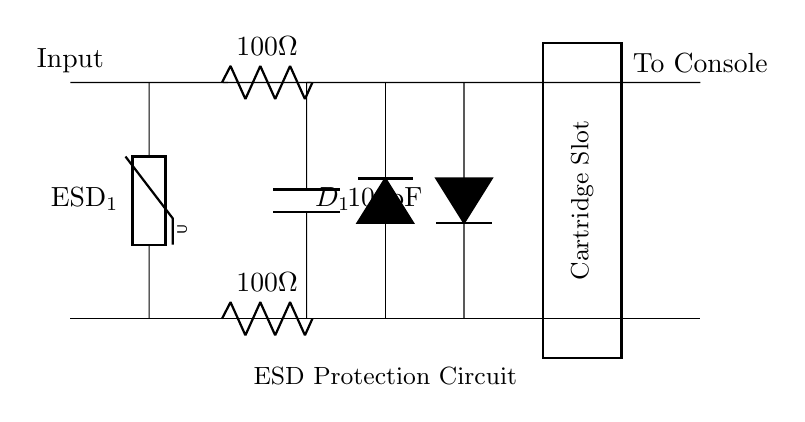What components are used for ESD protection? The circuit includes a varistor labeled ESD_1, which is a component specifically designed to absorb and protect against voltage spikes like electrostatic discharge (ESD).
Answer: Varistor What is the capacitance value in this circuit? The circuit diagram indicates a capacitor with a label of 100pF, which is the capacitance value providing filtering and stability in the circuit during ESD events.
Answer: 100pF How many resistors are present in the circuit? There are two resistors shown in the diagram, each labeled as 100 ohms. They are connected in parallel to provide resistance for ESD protection.
Answer: Two What is the configuration of the diodes in this circuit? The circuit diagram shows two diodes configured in opposing directions, which allows the circuit to conduct in both voltage polarities during ESD events, thus providing effective protection.
Answer: Opposing directions How does the capacitor impact the ESD protection? The capacitor works in conjunction with the varistor and diodes to shunt high-frequency noise and voltage spikes away from sensitive components. The 100pF capacitor's rapid charge and discharge capabilities help absorb ESD transients effectively.
Answer: Absorbs ESD transients What is the function of the cartridge slot in this circuit? The cartridge slot serves as the point where the gaming cartridge connects to the system, and it is protected by the ESD circuitry to prevent damage from electrostatic discharge occurring during cartridge insertion or removal.
Answer: Connection point for gaming cartridge 